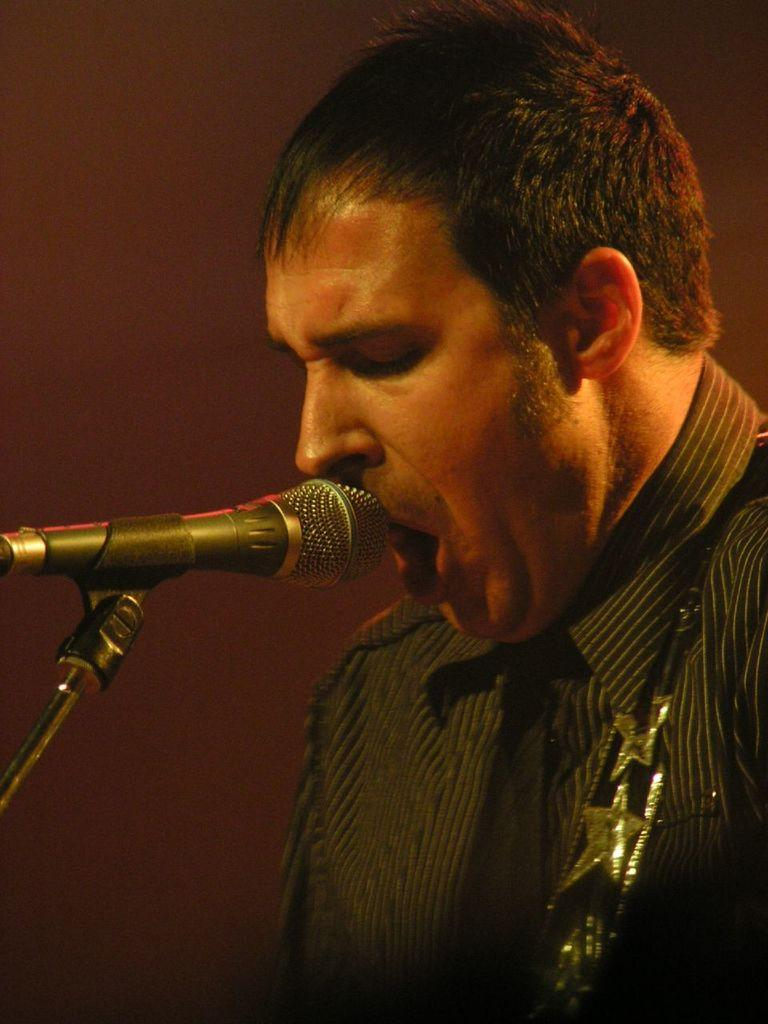Who or what is the main subject of the image? There is a person in the image. What object is in front of the person? There is a mic with a mic stand in front of the person. Can you describe the background of the image? The background of the image is dark. What type of apparatus is being used to dig a hole in the image? There is no apparatus for digging a hole present in the image. Can you tell me how many pails of water are being used by the person in the image? There is no pail or water present in the image. 